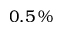<formula> <loc_0><loc_0><loc_500><loc_500>0 . 5 \, \%</formula> 